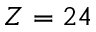<formula> <loc_0><loc_0><loc_500><loc_500>Z = 2 4</formula> 